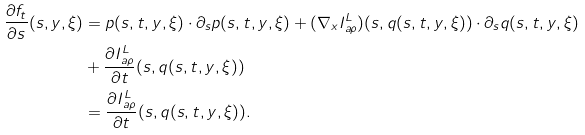Convert formula to latex. <formula><loc_0><loc_0><loc_500><loc_500>\frac { { \partial } f _ { t } } { { \partial } s } ( s , y , \xi ) & = p ( s , t , y , \xi ) \cdot { \partial } _ { s } p ( s , t , y , \xi ) + ( \nabla _ { x } I ^ { L } _ { a \rho } ) ( s , q ( s , t , y , \xi ) ) \cdot { \partial } _ { s } q ( s , t , y , \xi ) \\ & + \frac { { \partial } I ^ { L } _ { a \rho } } { { \partial } t } ( s , q ( s , t , y , \xi ) ) \\ & = \frac { { \partial } I ^ { L } _ { a \rho } } { { \partial } t } ( s , q ( s , t , y , \xi ) ) .</formula> 